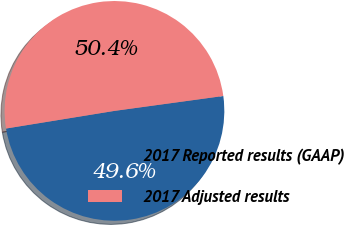Convert chart to OTSL. <chart><loc_0><loc_0><loc_500><loc_500><pie_chart><fcel>2017 Reported results (GAAP)<fcel>2017 Adjusted results<nl><fcel>49.6%<fcel>50.4%<nl></chart> 